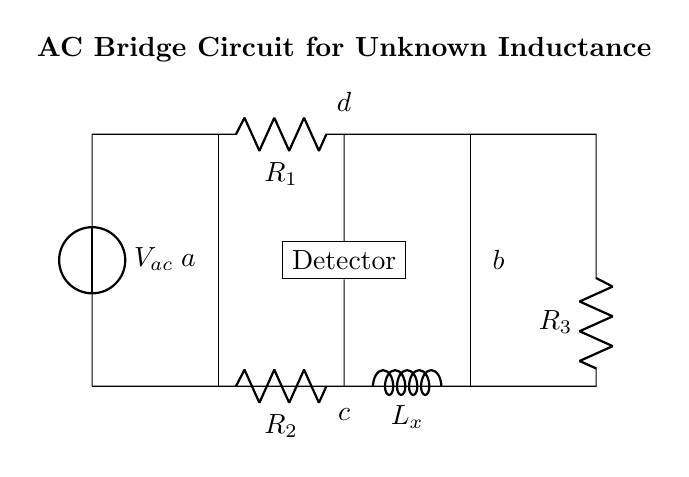What is the type of this circuit? The circuit is an AC bridge circuit, specifically used for measuring unknown inductance in coils. This is evident from the configuration and the presence of a detector along with inductors and resistors.
Answer: AC bridge What components are in the circuit? The circuit consists of two resistors (R1, R2), one inductor (Lx), and a voltage source (Vac), along with a detector. This information can be obtained by observing the labels in the diagram.
Answer: R1, R2, Lx, Vac What is the function of the detector? The detector's function is to indicate the balance condition of the bridge. When the bridge is balanced, the detector shows zero deflection, which helps in determining the unknown inductance accurately.
Answer: Balance indicator Where are the points for measuring current located? Current can be measured through the branches where R1, R2, and Lx are connected. Each of these components would have current flowing through them, which can be accessed by placing ammeters in those branches.
Answer: Across R1, R2, and Lx How many resistors are in this circuit? There are three resistors in total: R1, R2, and R3. From the diagram, this can be confirmed by identifying the labeled resistors connected in the circuit.
Answer: Three What determines the unknown inductance (Lx) in this circuit? The unknown inductance (Lx) is determined by adjusting the values of R1, R2, and R3 until the bridge is balanced (indicated by the detector). At this state, the relationship between these components allows for the calculation of Lx.
Answer: Values of R1, R2, R3 What does the voltage source represent in the circuit? The voltage source (Vac) represents the alternating current input necessary to operate the AC bridge circuit. It provides the necessary alternating voltage for the inductive and resistive components to function and interact.
Answer: Alternating current input 